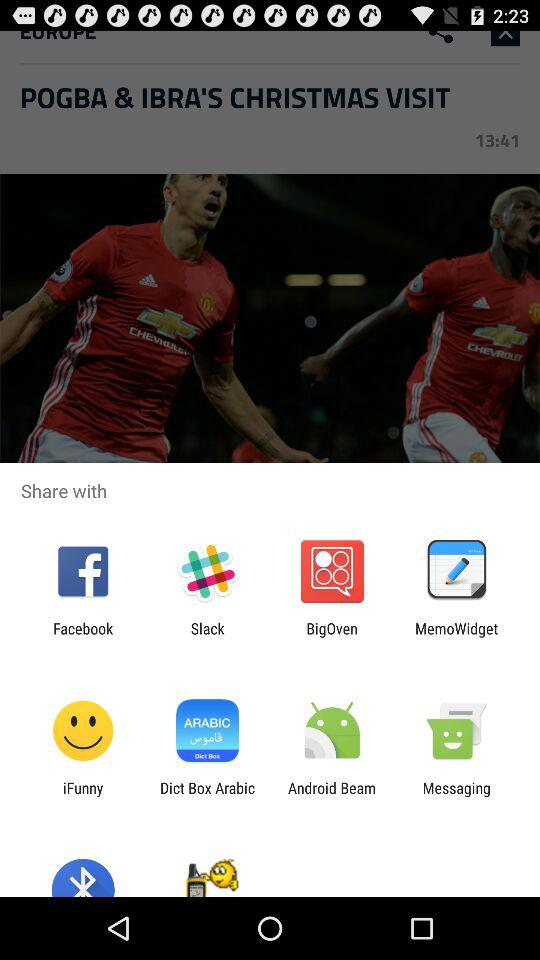Who wrote "POGBA & IBRA'S CHRISTMAS VISIT"?
When the provided information is insufficient, respond with <no answer>. <no answer> 